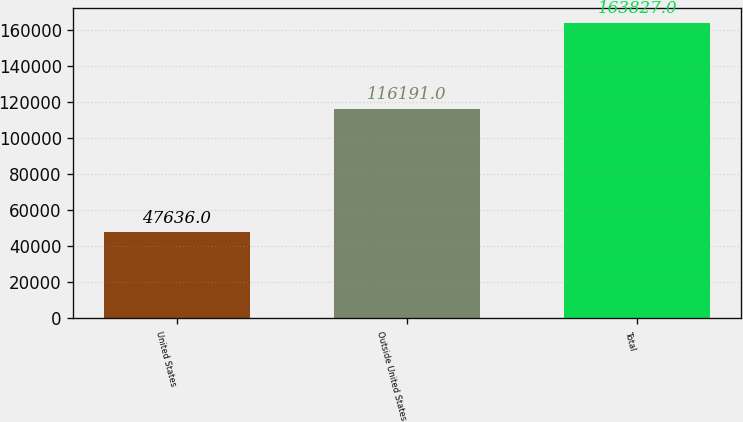<chart> <loc_0><loc_0><loc_500><loc_500><bar_chart><fcel>United States<fcel>Outside United States<fcel>Total<nl><fcel>47636<fcel>116191<fcel>163827<nl></chart> 